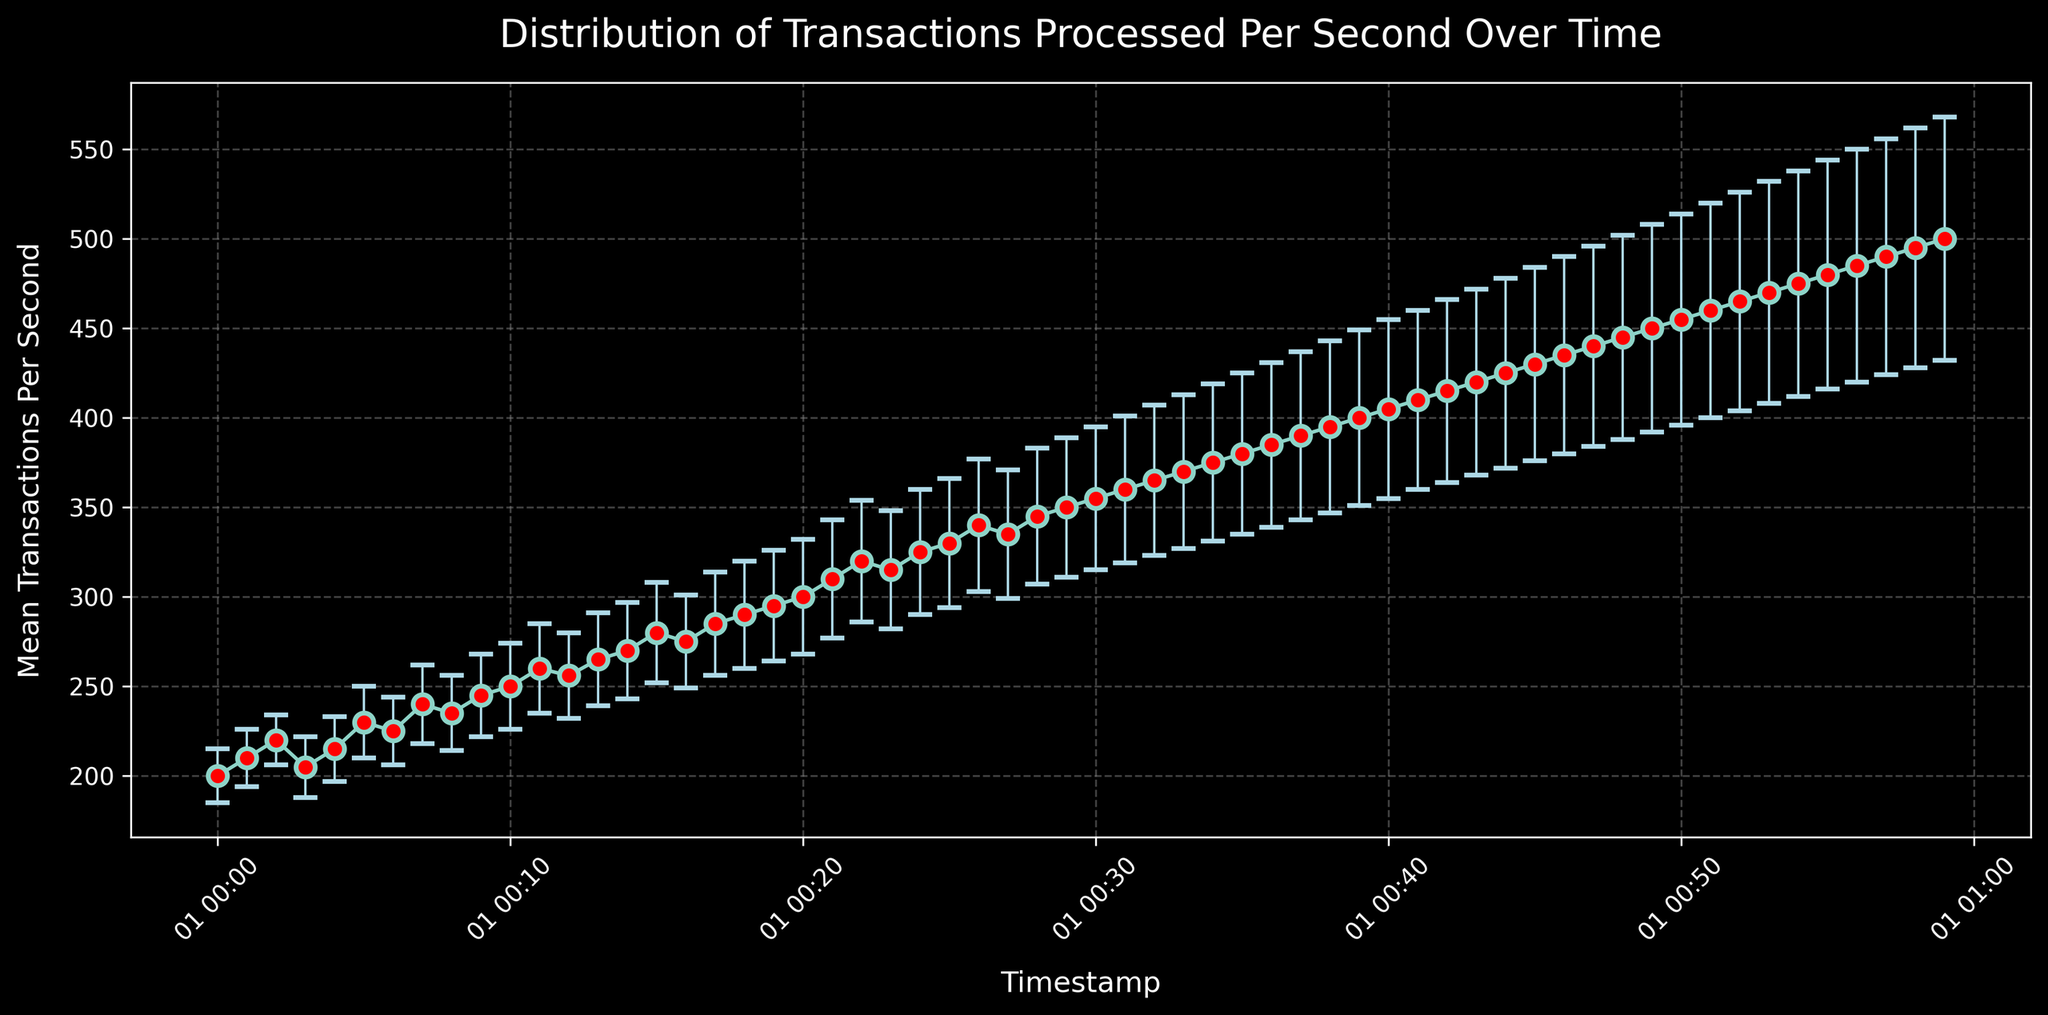What's the general trend of mean transactions per second over time? Observing the graph, the mean transactions per second consistently increase from the start to the end of the specified time period. This consistent increase indicates a general upward trend.
Answer: Upward trend What is the mean transactions per second at the start and at the end of the time period? At the start timestamp (2023-01-01T00:00:00Z), the mean transactions per second is 200. At the end timestamp (2023-01-01T00:59:00Z), it is 500. Therefore at the start, it is 200 and at the end, it is 500.
Answer: 200 and 500 What is the highest mean transactions per second recorded in the time period shown? By looking at the data points, the highest mean transactions per second recorded is at the end timestamp (2023-01-01T00:59:00Z) which is 500.
Answer: 500 How does the standard deviation change over time, and what could this signify? Observing the error bars, they progressively get larger towards the end of the time period, indicating that the standard deviation increases over time. This signifies increasing variability in the number of transactions processed per second over the observed period.
Answer: Increases Which timestamp shows the greatest relative variability in transactions per second and how can you tell? The greatest relative variability is shown at the timestamp (2023-01-01T00:20:00Z), with a standard deviation of 32. Compared to the mean (300), the larger standard deviation indicates higher relative variability.
Answer: 2023-01-01T00:20:00Z Considering the timestamps at 2023-01-01T00:00:00Z and 2023-01-01T00:59:00Z, how much did the mean transactions per second change, and what is the average rate of change per minute? The mean transactions per second at the start (00:00:00Z) is 200, and at the end (00:59:00Z) it is 500. The change is 500 - 200 = 300 transactions per second. There are 59 minutes between these timestamps. So, the average rate of change is  300 transactions / 59 minutes ≈ 5.08 transactions per second per minute.
Answer: 300, ≈ 5.08 At which timestamp does the standard deviation exceed 50 for the first time, and what does this indicate about the transactions per second at that point? The standard deviation exceeds 50 for the first time at timestamp (2023-01-01T00:40:00Z). This indicates a notably higher inconsistency in the number of transactions processed per second from this point onward.
Answer: 2023-01-01T00:40:00Z Which timestamps show a dip in the mean transactions per second, and what could be one possible explanation for these observations? Minor dips are observed at 2023-01-01T00:03:00Z and 2023-01-01T00:16:00Z in the mean transactions per second when comparing the surrounding data points. Possible explanations could be system hiccups or temporary reductions in transaction load.
Answer: 2023-01-01T00:03:00Z and 2023-01-01T00:16:00Z 